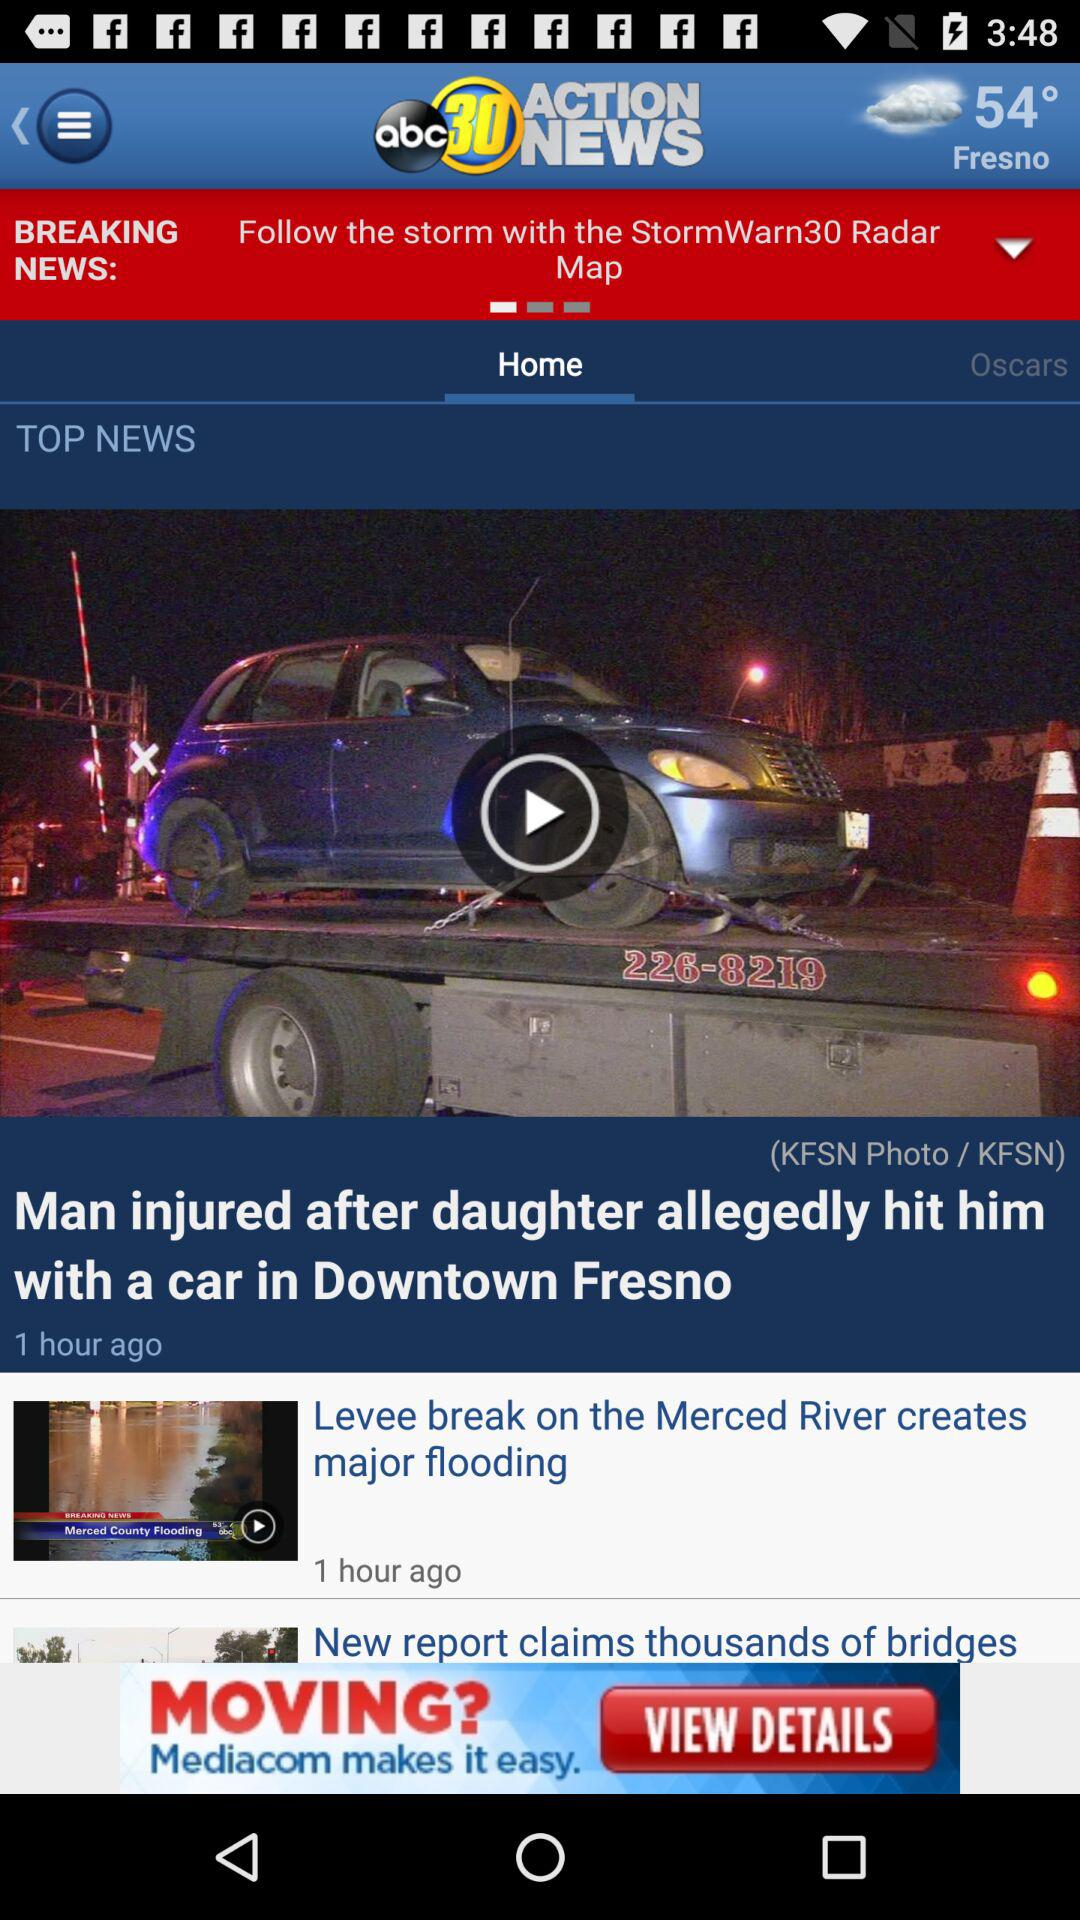What is the temperature today? The temperature is 54°. 